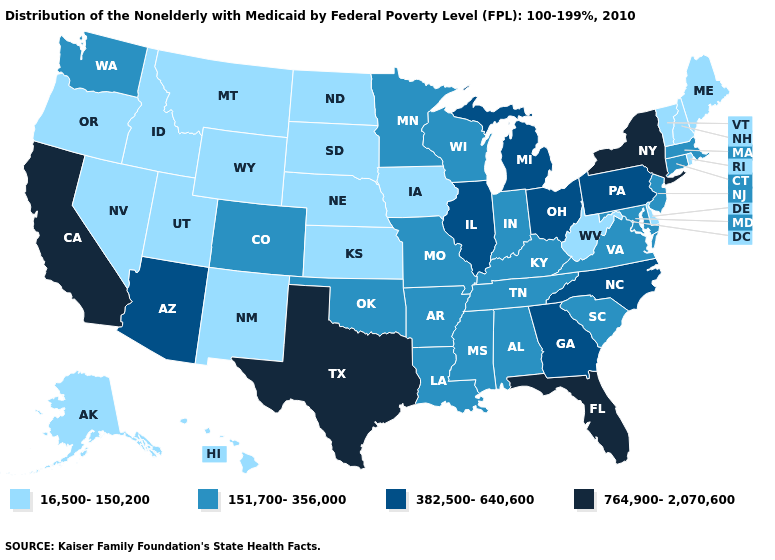Name the states that have a value in the range 382,500-640,600?
Write a very short answer. Arizona, Georgia, Illinois, Michigan, North Carolina, Ohio, Pennsylvania. Is the legend a continuous bar?
Answer briefly. No. Among the states that border Louisiana , does Texas have the highest value?
Quick response, please. Yes. What is the highest value in the USA?
Keep it brief. 764,900-2,070,600. Does New York have the highest value in the Northeast?
Quick response, please. Yes. Name the states that have a value in the range 151,700-356,000?
Answer briefly. Alabama, Arkansas, Colorado, Connecticut, Indiana, Kentucky, Louisiana, Maryland, Massachusetts, Minnesota, Mississippi, Missouri, New Jersey, Oklahoma, South Carolina, Tennessee, Virginia, Washington, Wisconsin. Which states have the lowest value in the MidWest?
Keep it brief. Iowa, Kansas, Nebraska, North Dakota, South Dakota. Does the first symbol in the legend represent the smallest category?
Give a very brief answer. Yes. Which states hav the highest value in the South?
Keep it brief. Florida, Texas. Is the legend a continuous bar?
Be succinct. No. Name the states that have a value in the range 382,500-640,600?
Quick response, please. Arizona, Georgia, Illinois, Michigan, North Carolina, Ohio, Pennsylvania. Among the states that border North Dakota , which have the lowest value?
Quick response, please. Montana, South Dakota. Name the states that have a value in the range 764,900-2,070,600?
Write a very short answer. California, Florida, New York, Texas. Does the first symbol in the legend represent the smallest category?
Answer briefly. Yes. Name the states that have a value in the range 764,900-2,070,600?
Answer briefly. California, Florida, New York, Texas. 